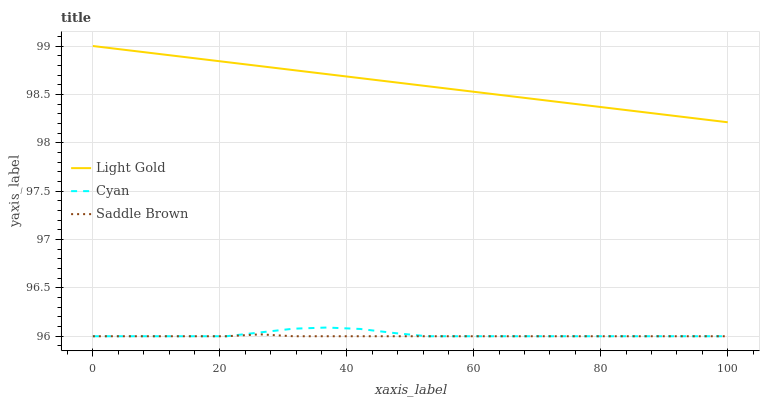Does Light Gold have the minimum area under the curve?
Answer yes or no. No. Does Saddle Brown have the maximum area under the curve?
Answer yes or no. No. Is Saddle Brown the smoothest?
Answer yes or no. No. Is Saddle Brown the roughest?
Answer yes or no. No. Does Light Gold have the lowest value?
Answer yes or no. No. Does Saddle Brown have the highest value?
Answer yes or no. No. Is Cyan less than Light Gold?
Answer yes or no. Yes. Is Light Gold greater than Cyan?
Answer yes or no. Yes. Does Cyan intersect Light Gold?
Answer yes or no. No. 